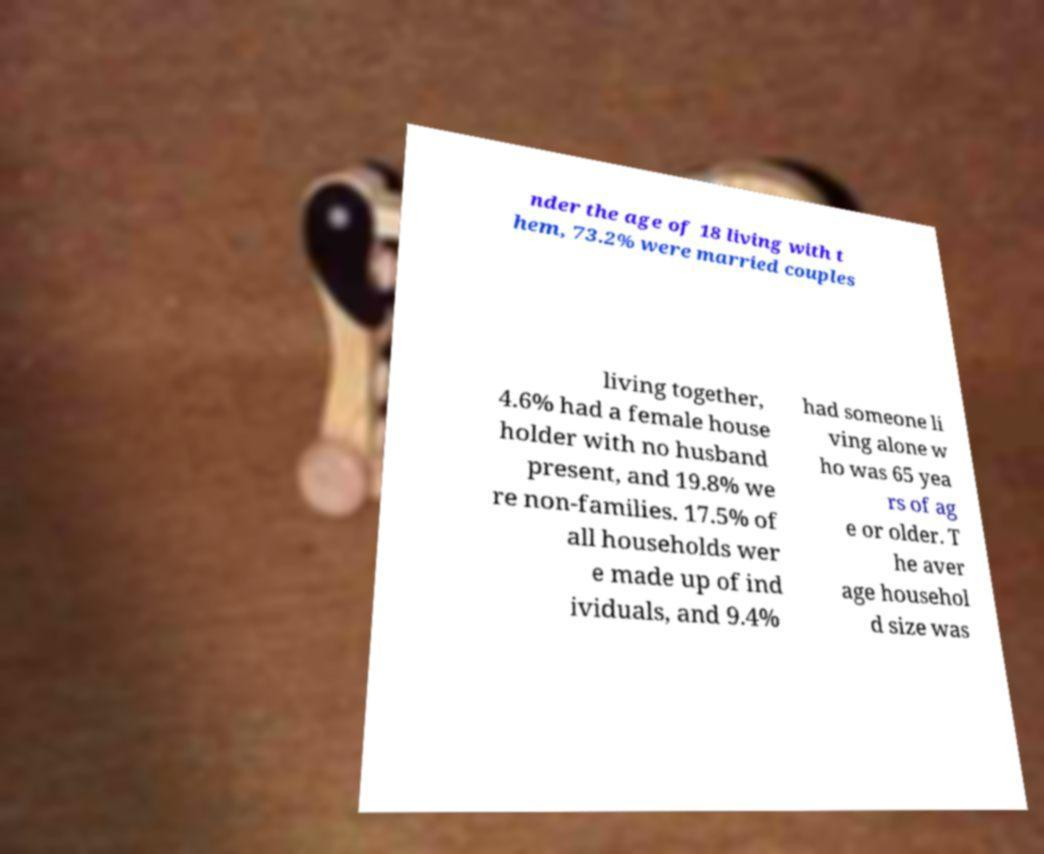Please read and relay the text visible in this image. What does it say? nder the age of 18 living with t hem, 73.2% were married couples living together, 4.6% had a female house holder with no husband present, and 19.8% we re non-families. 17.5% of all households wer e made up of ind ividuals, and 9.4% had someone li ving alone w ho was 65 yea rs of ag e or older. T he aver age househol d size was 